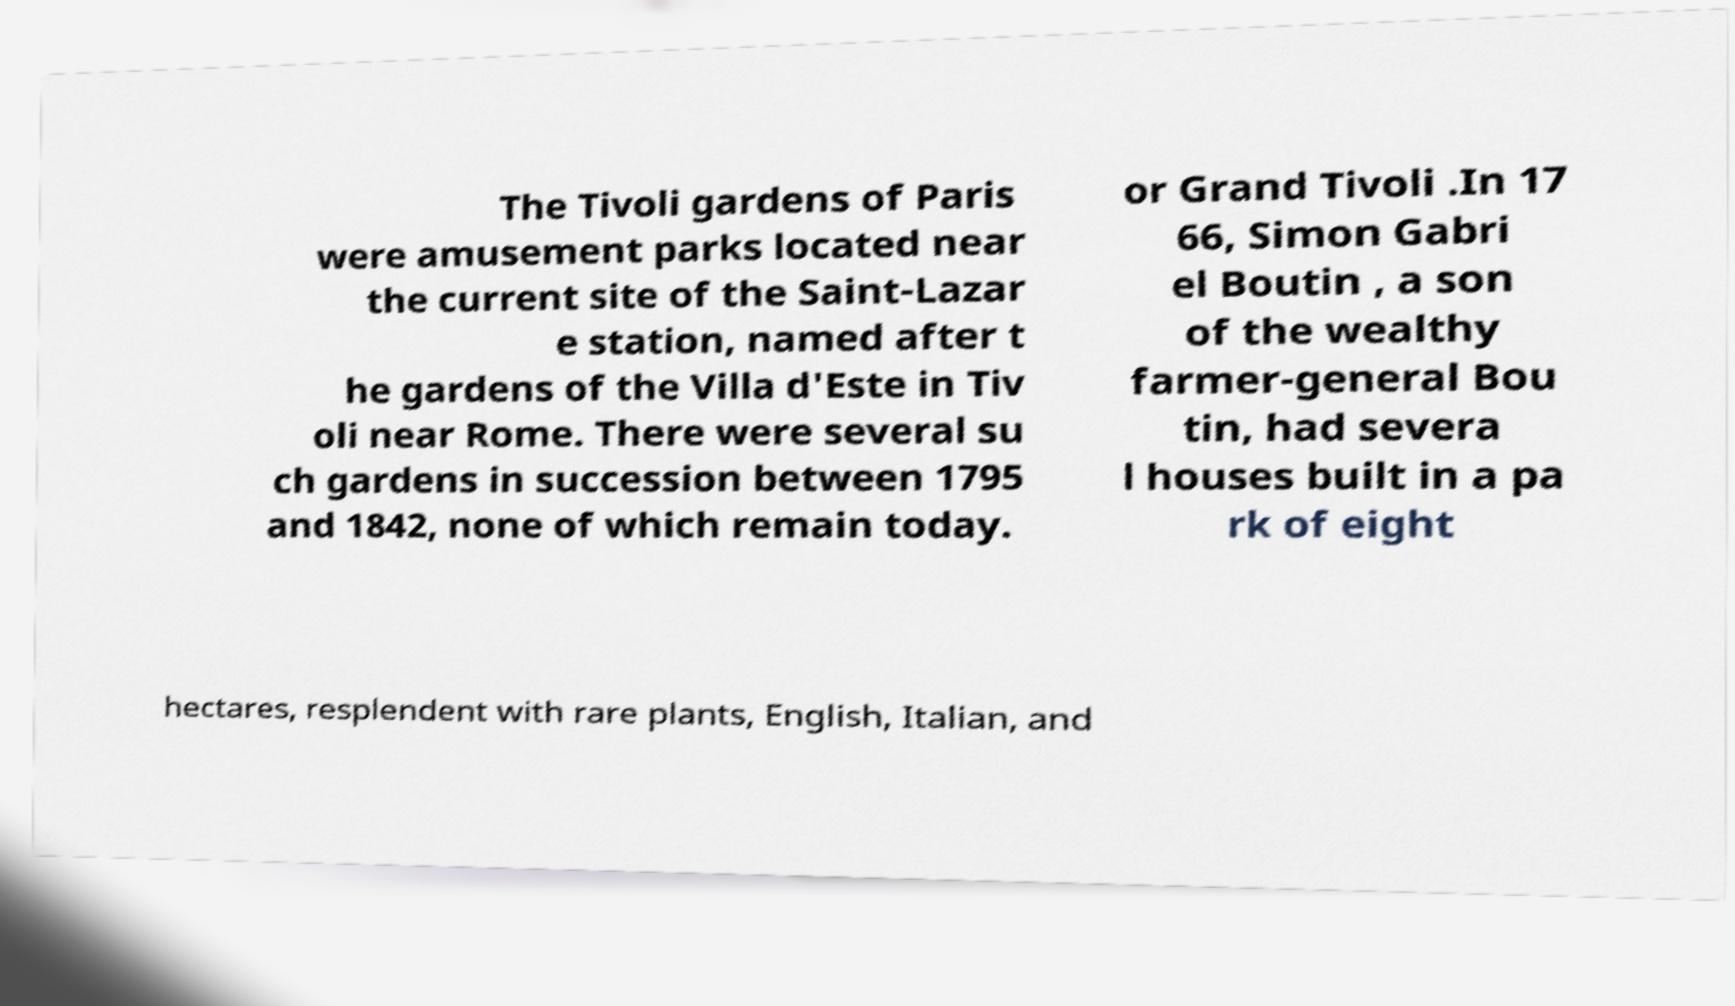Please read and relay the text visible in this image. What does it say? The Tivoli gardens of Paris were amusement parks located near the current site of the Saint-Lazar e station, named after t he gardens of the Villa d'Este in Tiv oli near Rome. There were several su ch gardens in succession between 1795 and 1842, none of which remain today. or Grand Tivoli .In 17 66, Simon Gabri el Boutin , a son of the wealthy farmer-general Bou tin, had severa l houses built in a pa rk of eight hectares, resplendent with rare plants, English, Italian, and 